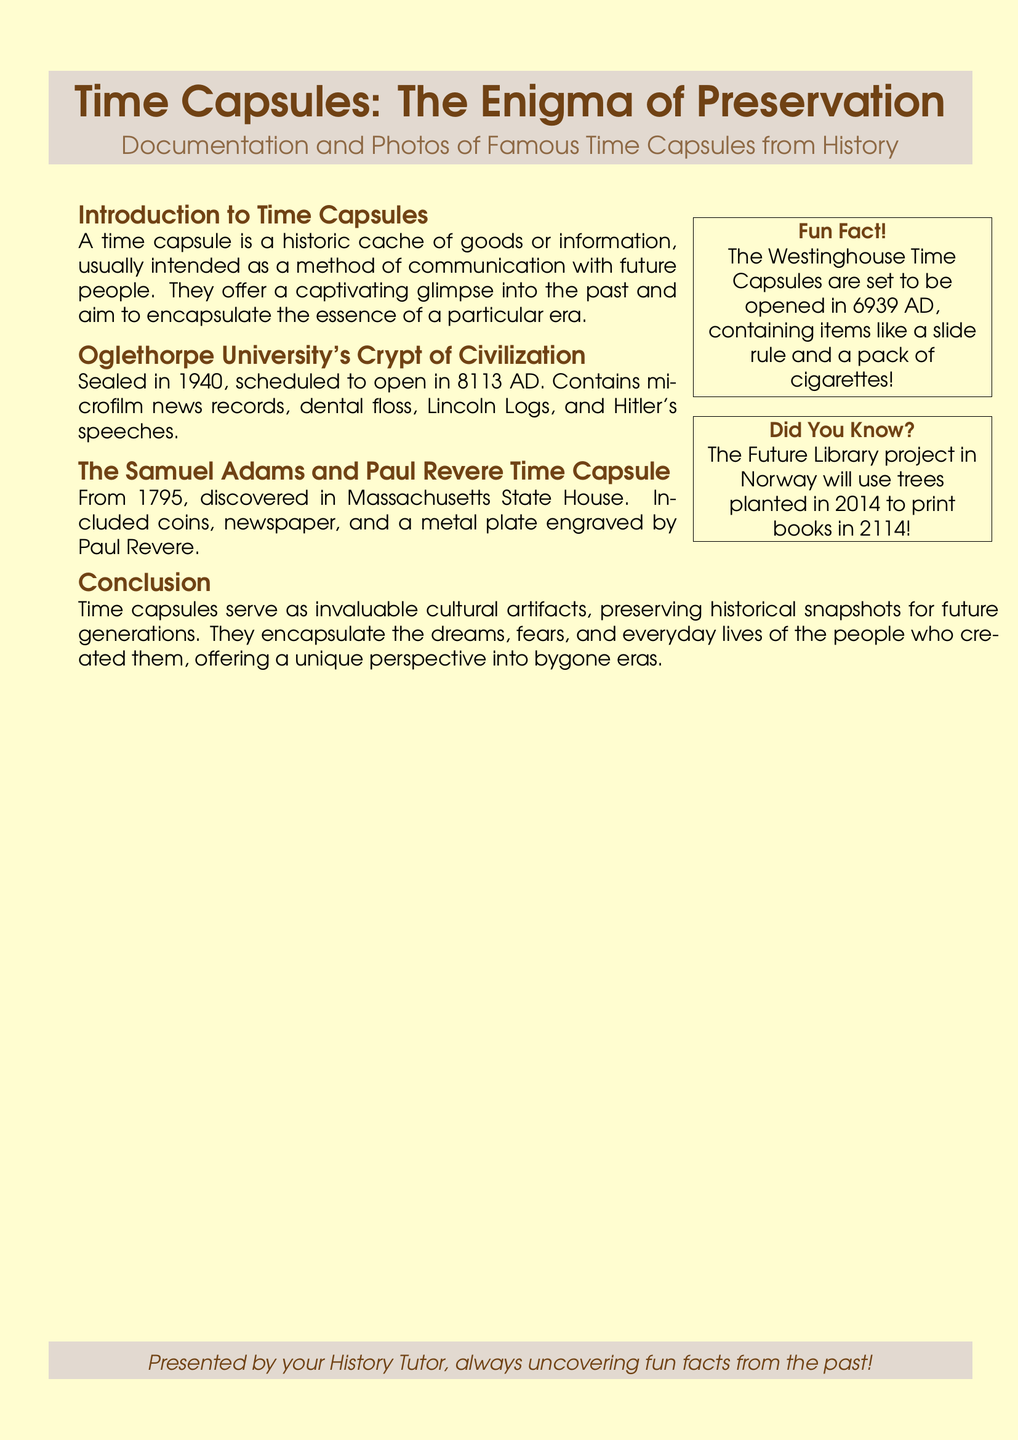What year was the Oglethorpe University's Crypt of Civilization sealed? The document states that it was sealed in 1940.
Answer: 1940 What is the scheduled opening year of the Oglethorpe University's Crypt of Civilization? According to the document, it is scheduled to open in 8113 AD.
Answer: 8113 AD What significant item was included in the 1795 Samuel Adams and Paul Revere Time Capsule? The document mentions that it included a metal plate engraved by Paul Revere.
Answer: Metal plate What unique item is mentioned in the Westinghouse Time Capsules? The document lists a slide rule as one of the items it contains.
Answer: Slide rule What year will the Future Library project in Norway produce books? The document indicates that it will produce books in 2114.
Answer: 2114 What type of content do time capsules typically aim to capture? The introduction states that they aim to encapsulate the essence of a particular era.
Answer: Essence What does the conclusion say about time capsules? It states that they are invaluable cultural artifacts.
Answer: Invaluable cultural artifacts What are sealed time capsules intended to communicate with? The document mentions communication with future people.
Answer: Future people 